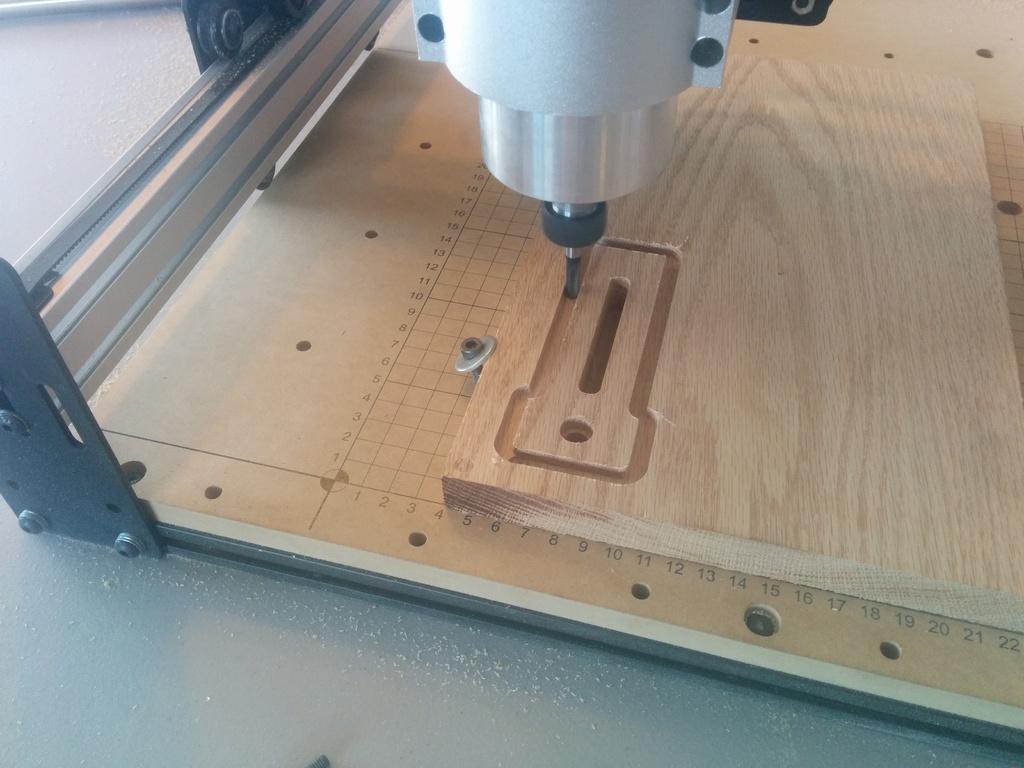Could you give a brief overview of what you see in this image? There is a plywood and a drilling machine above it. There are holes on the wood and there is are scale marking. 